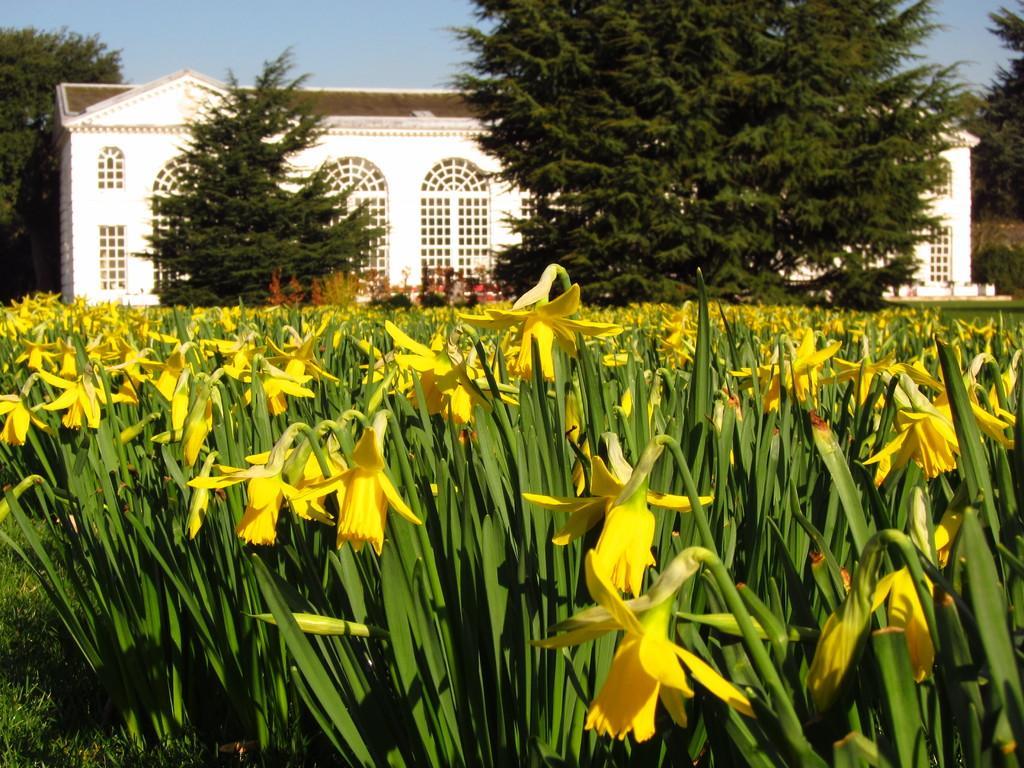Could you give a brief overview of what you see in this image? In this picture I can see a building and few trees and I can see plants, flowers and a blue sky. 